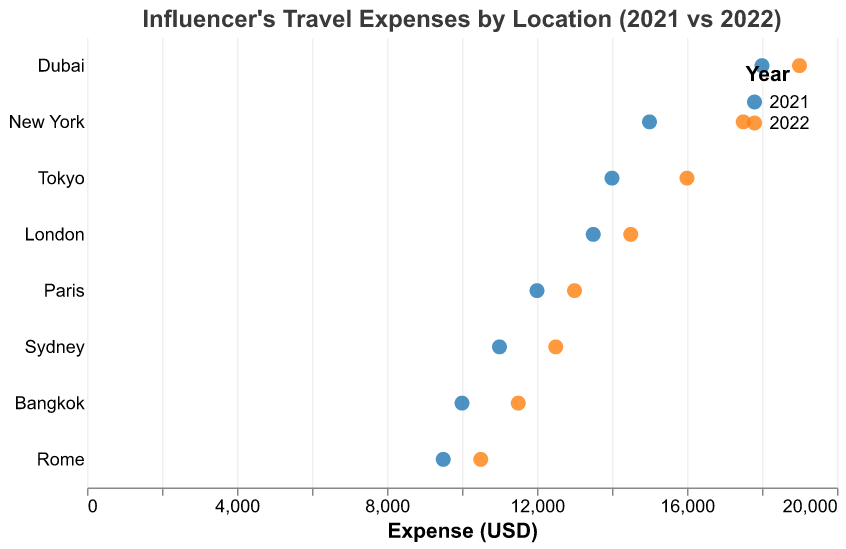What is the title of the figure? The title of the figure is found at the top, usually centered, and summarizes the content of the plot. In this case, it should provide information on what is being compared and the subject of the data.
Answer: Influencer's Travel Expenses by Location (2021 vs 2022) Which location had the highest travel expense in 2022? To determine the location with the highest travel expense in 2022, look at the expense values for all locations and identify the maximum value for the year 2022.
Answer: Dubai How much did the influencer's travel expenses increase in New York from 2021 to 2022? To find the increase, subtract the 2021 expense value for New York from the 2022 expense value for New York.
Answer: 2500 Which location experienced the smallest increase in travel expenses between 2021 and 2022? Calculate the increase in expenses for each location by subtracting the 2021 value from the 2022 value for each location. Compare these increases to identify the smallest one.
Answer: Paris How does the travel expense change for Tokyo compare between 2021 and 2022? Identify the expense values for Tokyo in both years. Compare these values to determine whether there was an increase, decrease, or no change.
Answer: Increase by 2000 What is the total sum of the influencer's travel expenses for all locations in 2021? Sum up the 2021 expenses for all locations. Add up all the individual values: 15000 + 12000 + 14000 + 13500 + 11000 + 18000 + 9500 + 10000.
Answer: 103000 Which two locations had the closest travel expenses in 2022? Compare the expenses for all locations in 2022 to find the two values that are closest to each other.
Answer: Rome and Bangkok What is the average travel expense in 2021 across all the locations? Calculate the average by summing up all the 2021 expenses and dividing by the number of locations. (15000 + 12000 + 14000 + 13500 + 11000 + 18000 + 9500 + 10000) / 8.
Answer: 12875 Between which two locations did the travel expenses differ the most in 2022? Identify the maximum and minimum expense values in 2022 and determine the locations associated with these values. Calculate the difference and determine the corresponding locations.
Answer: Dubai and Rome In which year did the influencer spend more in Sydney, and by how much? Compare the expense values for Sydney in 2021 and 2022 and calculate the difference.
Answer: 2022 by 1500 